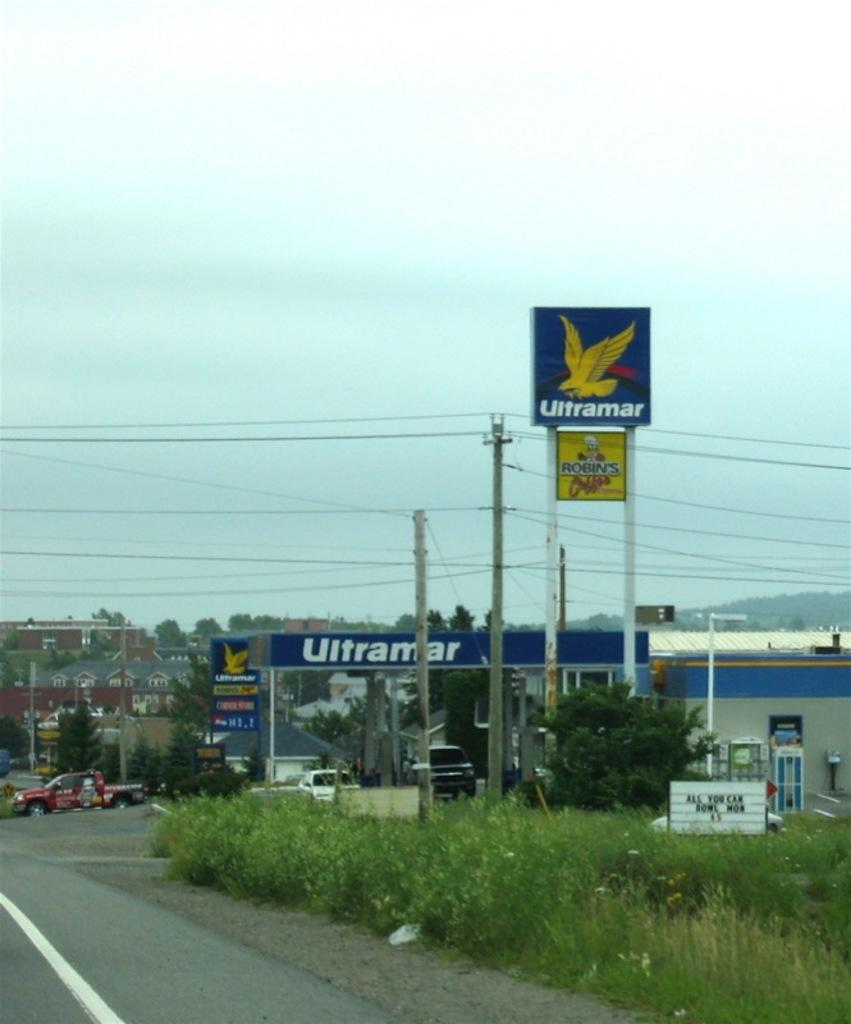<image>
Summarize the visual content of the image. an ultramar sign in a little town area 